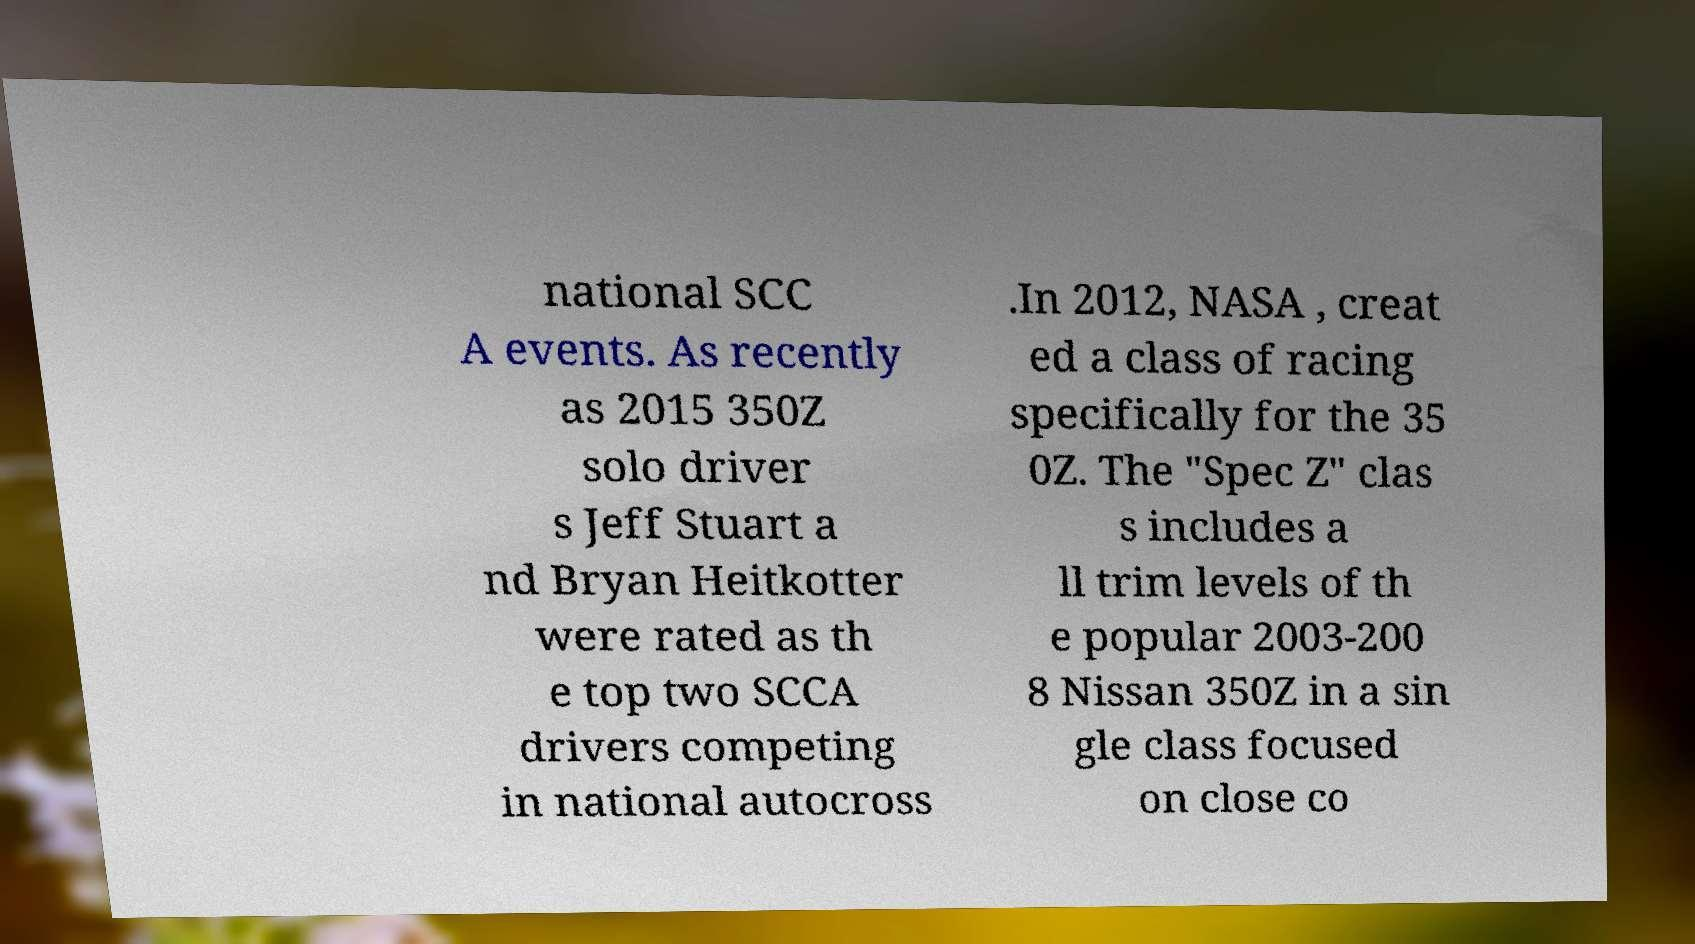I need the written content from this picture converted into text. Can you do that? national SCC A events. As recently as 2015 350Z solo driver s Jeff Stuart a nd Bryan Heitkotter were rated as th e top two SCCA drivers competing in national autocross .In 2012, NASA , creat ed a class of racing specifically for the 35 0Z. The "Spec Z" clas s includes a ll trim levels of th e popular 2003-200 8 Nissan 350Z in a sin gle class focused on close co 